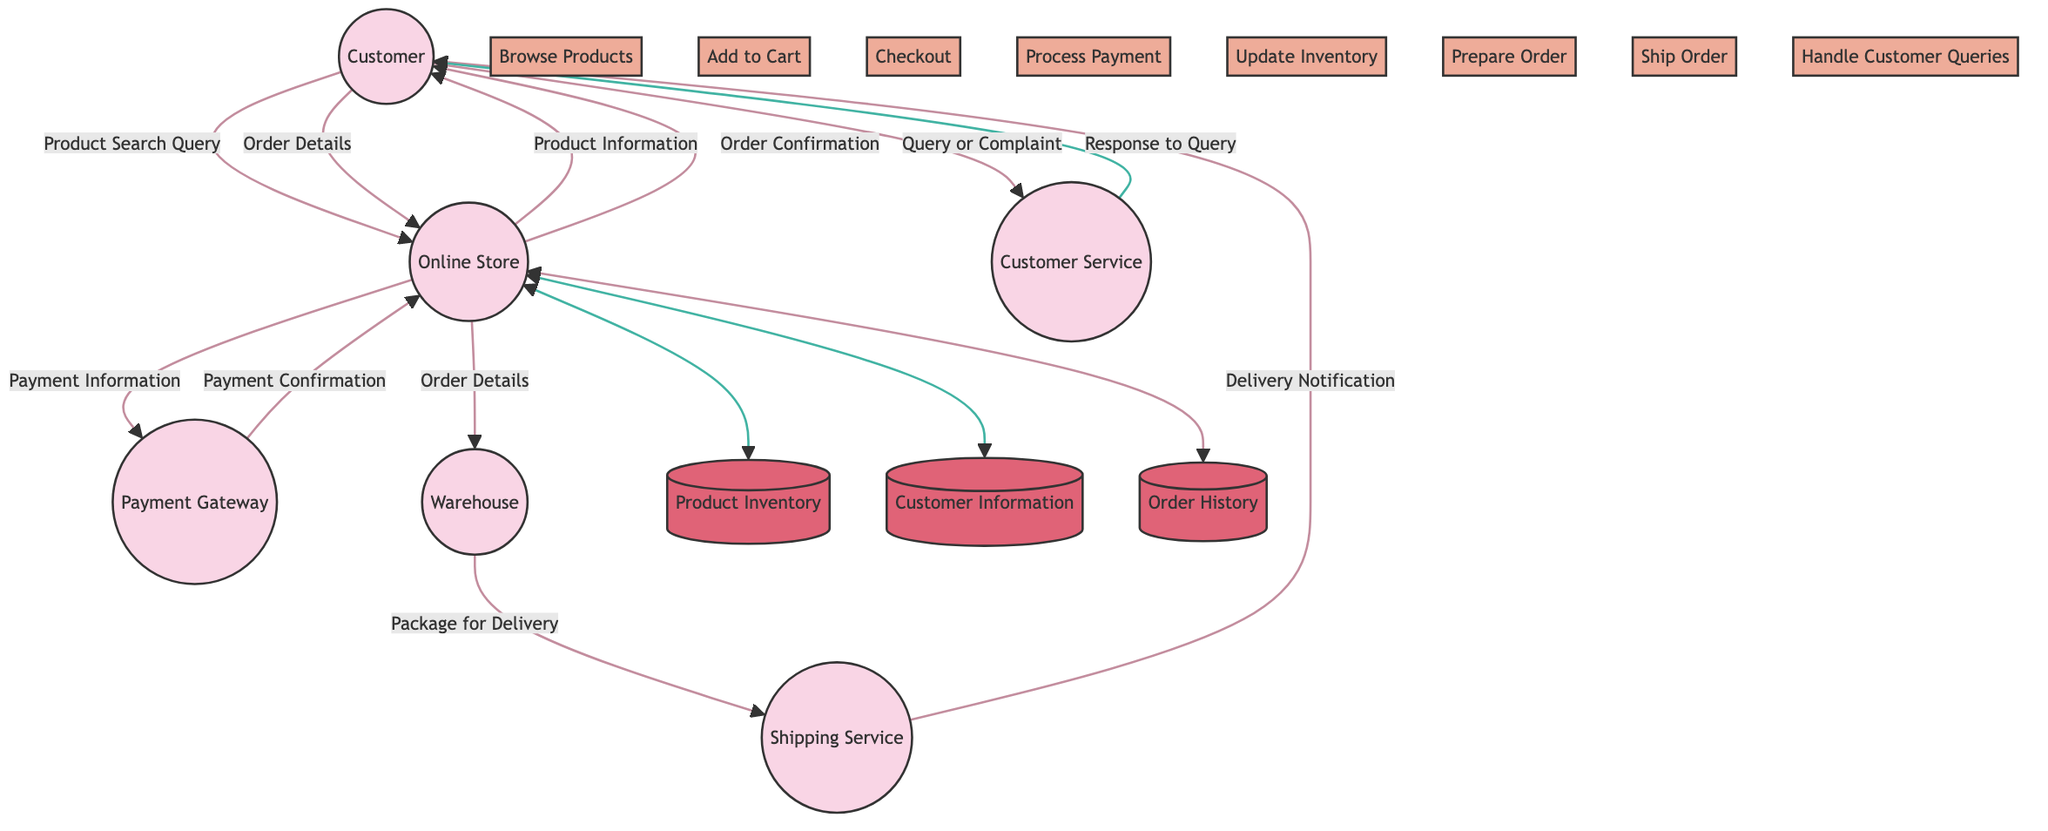What is the first process a Customer engages in? The first process a Customer engages in is depicted as the first process in the diagram from the Customer to the Online Store, which is "Browse Products".
Answer: Browse Products How many entities are in the diagram? The diagram contains a total of six entities: Customer, Online Store, Payment Gateway, Warehouse, Shipping Service, and Customer Service. Counting them gives a total of six.
Answer: Six What data does the Online Store send to the Customer after the Checkout process? After the Checkout process, the Online Store sends "Order Confirmation" to the Customer, as shown in the data flow indicating this output.
Answer: Order Confirmation Which service is responsible for delivering the products to the Customer? The Shipping Service is specifically mentioned in the flow chart as the entity responsible for delivering products to the Customer.
Answer: Shipping Service What is the process that follows after the Payment Confirmation from Payment Gateway to Online Store? After the Payment Confirmation is received by the Online Store from the Payment Gateway, the next process is "Update Inventory", indicating that the store updates the stock levels.
Answer: Update Inventory What kind of information flows from the Customer to the Customer Service? The information that flows from the Customer to the Customer Service is described as "Query or Complaint" in the data flows, representing the customer's inquiries or issues.
Answer: Query or Complaint How does the Warehouse receive information regarding the order? The Warehouse receives information regarding the order through the "Order Details" which is sent from the Online Store to the Warehouse after the checkout process is completed.
Answer: Order Details What is the final notification received by the Customer? The final notification received by the Customer is a "Delivery Notification", which is sent from the Shipping Service confirming that the product is on its way or has been delivered.
Answer: Delivery Notification 